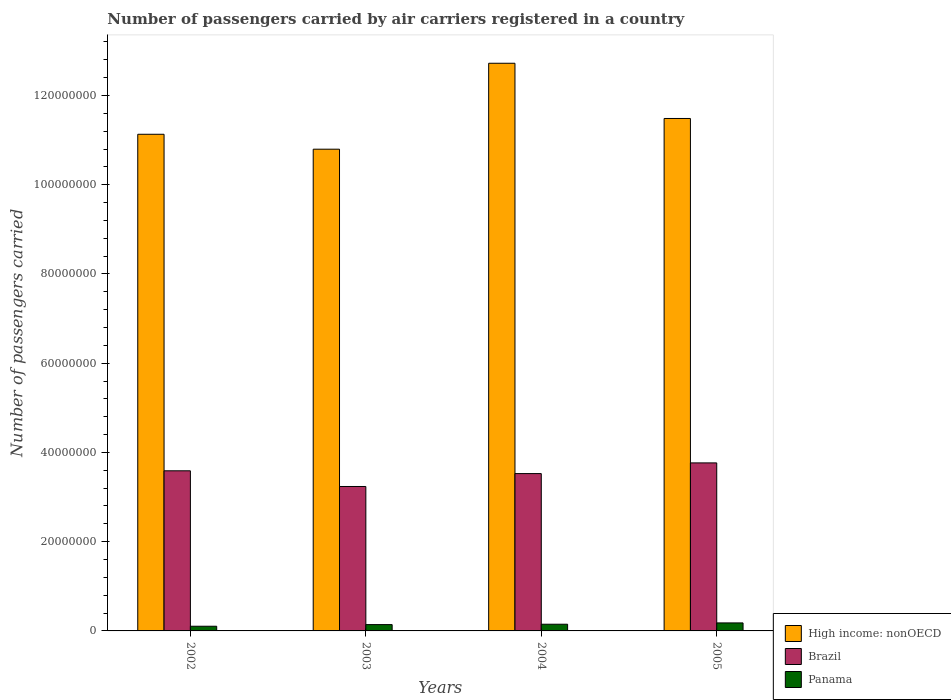How many different coloured bars are there?
Keep it short and to the point. 3. Are the number of bars per tick equal to the number of legend labels?
Your answer should be very brief. Yes. Are the number of bars on each tick of the X-axis equal?
Provide a short and direct response. Yes. In how many cases, is the number of bars for a given year not equal to the number of legend labels?
Make the answer very short. 0. What is the number of passengers carried by air carriers in Panama in 2005?
Your response must be concise. 1.80e+06. Across all years, what is the maximum number of passengers carried by air carriers in Brazil?
Your answer should be very brief. 3.77e+07. Across all years, what is the minimum number of passengers carried by air carriers in Brazil?
Provide a short and direct response. 3.24e+07. In which year was the number of passengers carried by air carriers in Panama maximum?
Your answer should be compact. 2005. In which year was the number of passengers carried by air carriers in High income: nonOECD minimum?
Your answer should be very brief. 2003. What is the total number of passengers carried by air carriers in High income: nonOECD in the graph?
Ensure brevity in your answer.  4.61e+08. What is the difference between the number of passengers carried by air carriers in Brazil in 2002 and that in 2004?
Give a very brief answer. 6.26e+05. What is the difference between the number of passengers carried by air carriers in Brazil in 2002 and the number of passengers carried by air carriers in Panama in 2004?
Provide a succinct answer. 3.44e+07. What is the average number of passengers carried by air carriers in Panama per year?
Provide a short and direct response. 1.44e+06. In the year 2003, what is the difference between the number of passengers carried by air carriers in High income: nonOECD and number of passengers carried by air carriers in Panama?
Keep it short and to the point. 1.07e+08. What is the ratio of the number of passengers carried by air carriers in High income: nonOECD in 2003 to that in 2005?
Offer a terse response. 0.94. Is the number of passengers carried by air carriers in Brazil in 2002 less than that in 2003?
Offer a terse response. No. Is the difference between the number of passengers carried by air carriers in High income: nonOECD in 2002 and 2005 greater than the difference between the number of passengers carried by air carriers in Panama in 2002 and 2005?
Give a very brief answer. No. What is the difference between the highest and the second highest number of passengers carried by air carriers in Brazil?
Offer a terse response. 1.77e+06. What is the difference between the highest and the lowest number of passengers carried by air carriers in Brazil?
Your response must be concise. 5.29e+06. In how many years, is the number of passengers carried by air carriers in High income: nonOECD greater than the average number of passengers carried by air carriers in High income: nonOECD taken over all years?
Offer a very short reply. 1. Is the sum of the number of passengers carried by air carriers in High income: nonOECD in 2004 and 2005 greater than the maximum number of passengers carried by air carriers in Panama across all years?
Your answer should be very brief. Yes. What does the 3rd bar from the left in 2002 represents?
Your response must be concise. Panama. What does the 2nd bar from the right in 2002 represents?
Keep it short and to the point. Brazil. Are all the bars in the graph horizontal?
Offer a very short reply. No. Does the graph contain grids?
Provide a short and direct response. No. How many legend labels are there?
Provide a succinct answer. 3. How are the legend labels stacked?
Offer a very short reply. Vertical. What is the title of the graph?
Offer a terse response. Number of passengers carried by air carriers registered in a country. Does "Europe(all income levels)" appear as one of the legend labels in the graph?
Give a very brief answer. No. What is the label or title of the X-axis?
Give a very brief answer. Years. What is the label or title of the Y-axis?
Give a very brief answer. Number of passengers carried. What is the Number of passengers carried of High income: nonOECD in 2002?
Give a very brief answer. 1.11e+08. What is the Number of passengers carried in Brazil in 2002?
Provide a short and direct response. 3.59e+07. What is the Number of passengers carried in Panama in 2002?
Give a very brief answer. 1.05e+06. What is the Number of passengers carried of High income: nonOECD in 2003?
Offer a terse response. 1.08e+08. What is the Number of passengers carried in Brazil in 2003?
Provide a short and direct response. 3.24e+07. What is the Number of passengers carried in Panama in 2003?
Your answer should be compact. 1.42e+06. What is the Number of passengers carried of High income: nonOECD in 2004?
Give a very brief answer. 1.27e+08. What is the Number of passengers carried of Brazil in 2004?
Provide a succinct answer. 3.53e+07. What is the Number of passengers carried of Panama in 2004?
Your answer should be compact. 1.50e+06. What is the Number of passengers carried in High income: nonOECD in 2005?
Keep it short and to the point. 1.15e+08. What is the Number of passengers carried of Brazil in 2005?
Offer a very short reply. 3.77e+07. What is the Number of passengers carried in Panama in 2005?
Your answer should be very brief. 1.80e+06. Across all years, what is the maximum Number of passengers carried of High income: nonOECD?
Give a very brief answer. 1.27e+08. Across all years, what is the maximum Number of passengers carried of Brazil?
Keep it short and to the point. 3.77e+07. Across all years, what is the maximum Number of passengers carried in Panama?
Offer a very short reply. 1.80e+06. Across all years, what is the minimum Number of passengers carried in High income: nonOECD?
Ensure brevity in your answer.  1.08e+08. Across all years, what is the minimum Number of passengers carried in Brazil?
Your answer should be very brief. 3.24e+07. Across all years, what is the minimum Number of passengers carried in Panama?
Your answer should be compact. 1.05e+06. What is the total Number of passengers carried of High income: nonOECD in the graph?
Ensure brevity in your answer.  4.61e+08. What is the total Number of passengers carried of Brazil in the graph?
Offer a very short reply. 1.41e+08. What is the total Number of passengers carried of Panama in the graph?
Provide a succinct answer. 5.76e+06. What is the difference between the Number of passengers carried in High income: nonOECD in 2002 and that in 2003?
Give a very brief answer. 3.34e+06. What is the difference between the Number of passengers carried in Brazil in 2002 and that in 2003?
Provide a succinct answer. 3.52e+06. What is the difference between the Number of passengers carried of Panama in 2002 and that in 2003?
Ensure brevity in your answer.  -3.68e+05. What is the difference between the Number of passengers carried in High income: nonOECD in 2002 and that in 2004?
Your answer should be compact. -1.59e+07. What is the difference between the Number of passengers carried in Brazil in 2002 and that in 2004?
Offer a very short reply. 6.26e+05. What is the difference between the Number of passengers carried of Panama in 2002 and that in 2004?
Provide a succinct answer. -4.53e+05. What is the difference between the Number of passengers carried of High income: nonOECD in 2002 and that in 2005?
Give a very brief answer. -3.54e+06. What is the difference between the Number of passengers carried in Brazil in 2002 and that in 2005?
Provide a short and direct response. -1.77e+06. What is the difference between the Number of passengers carried of Panama in 2002 and that in 2005?
Offer a very short reply. -7.48e+05. What is the difference between the Number of passengers carried of High income: nonOECD in 2003 and that in 2004?
Give a very brief answer. -1.93e+07. What is the difference between the Number of passengers carried in Brazil in 2003 and that in 2004?
Your response must be concise. -2.89e+06. What is the difference between the Number of passengers carried of Panama in 2003 and that in 2004?
Give a very brief answer. -8.46e+04. What is the difference between the Number of passengers carried of High income: nonOECD in 2003 and that in 2005?
Your answer should be compact. -6.89e+06. What is the difference between the Number of passengers carried of Brazil in 2003 and that in 2005?
Your answer should be compact. -5.29e+06. What is the difference between the Number of passengers carried in Panama in 2003 and that in 2005?
Keep it short and to the point. -3.80e+05. What is the difference between the Number of passengers carried of High income: nonOECD in 2004 and that in 2005?
Provide a short and direct response. 1.24e+07. What is the difference between the Number of passengers carried in Brazil in 2004 and that in 2005?
Ensure brevity in your answer.  -2.40e+06. What is the difference between the Number of passengers carried of Panama in 2004 and that in 2005?
Provide a short and direct response. -2.95e+05. What is the difference between the Number of passengers carried in High income: nonOECD in 2002 and the Number of passengers carried in Brazil in 2003?
Offer a very short reply. 7.89e+07. What is the difference between the Number of passengers carried of High income: nonOECD in 2002 and the Number of passengers carried of Panama in 2003?
Make the answer very short. 1.10e+08. What is the difference between the Number of passengers carried of Brazil in 2002 and the Number of passengers carried of Panama in 2003?
Your response must be concise. 3.45e+07. What is the difference between the Number of passengers carried of High income: nonOECD in 2002 and the Number of passengers carried of Brazil in 2004?
Offer a very short reply. 7.61e+07. What is the difference between the Number of passengers carried of High income: nonOECD in 2002 and the Number of passengers carried of Panama in 2004?
Your answer should be very brief. 1.10e+08. What is the difference between the Number of passengers carried in Brazil in 2002 and the Number of passengers carried in Panama in 2004?
Ensure brevity in your answer.  3.44e+07. What is the difference between the Number of passengers carried of High income: nonOECD in 2002 and the Number of passengers carried of Brazil in 2005?
Make the answer very short. 7.37e+07. What is the difference between the Number of passengers carried in High income: nonOECD in 2002 and the Number of passengers carried in Panama in 2005?
Provide a succinct answer. 1.10e+08. What is the difference between the Number of passengers carried of Brazil in 2002 and the Number of passengers carried of Panama in 2005?
Make the answer very short. 3.41e+07. What is the difference between the Number of passengers carried in High income: nonOECD in 2003 and the Number of passengers carried in Brazil in 2004?
Your answer should be compact. 7.27e+07. What is the difference between the Number of passengers carried of High income: nonOECD in 2003 and the Number of passengers carried of Panama in 2004?
Your answer should be very brief. 1.06e+08. What is the difference between the Number of passengers carried of Brazil in 2003 and the Number of passengers carried of Panama in 2004?
Offer a terse response. 3.09e+07. What is the difference between the Number of passengers carried of High income: nonOECD in 2003 and the Number of passengers carried of Brazil in 2005?
Offer a terse response. 7.03e+07. What is the difference between the Number of passengers carried in High income: nonOECD in 2003 and the Number of passengers carried in Panama in 2005?
Offer a terse response. 1.06e+08. What is the difference between the Number of passengers carried in Brazil in 2003 and the Number of passengers carried in Panama in 2005?
Keep it short and to the point. 3.06e+07. What is the difference between the Number of passengers carried of High income: nonOECD in 2004 and the Number of passengers carried of Brazil in 2005?
Your answer should be very brief. 8.96e+07. What is the difference between the Number of passengers carried in High income: nonOECD in 2004 and the Number of passengers carried in Panama in 2005?
Your response must be concise. 1.25e+08. What is the difference between the Number of passengers carried of Brazil in 2004 and the Number of passengers carried of Panama in 2005?
Your response must be concise. 3.35e+07. What is the average Number of passengers carried in High income: nonOECD per year?
Ensure brevity in your answer.  1.15e+08. What is the average Number of passengers carried in Brazil per year?
Your answer should be very brief. 3.53e+07. What is the average Number of passengers carried in Panama per year?
Your response must be concise. 1.44e+06. In the year 2002, what is the difference between the Number of passengers carried in High income: nonOECD and Number of passengers carried in Brazil?
Your response must be concise. 7.54e+07. In the year 2002, what is the difference between the Number of passengers carried in High income: nonOECD and Number of passengers carried in Panama?
Ensure brevity in your answer.  1.10e+08. In the year 2002, what is the difference between the Number of passengers carried in Brazil and Number of passengers carried in Panama?
Your response must be concise. 3.48e+07. In the year 2003, what is the difference between the Number of passengers carried of High income: nonOECD and Number of passengers carried of Brazil?
Offer a terse response. 7.56e+07. In the year 2003, what is the difference between the Number of passengers carried of High income: nonOECD and Number of passengers carried of Panama?
Provide a short and direct response. 1.07e+08. In the year 2003, what is the difference between the Number of passengers carried in Brazil and Number of passengers carried in Panama?
Give a very brief answer. 3.10e+07. In the year 2004, what is the difference between the Number of passengers carried of High income: nonOECD and Number of passengers carried of Brazil?
Your response must be concise. 9.20e+07. In the year 2004, what is the difference between the Number of passengers carried in High income: nonOECD and Number of passengers carried in Panama?
Make the answer very short. 1.26e+08. In the year 2004, what is the difference between the Number of passengers carried in Brazil and Number of passengers carried in Panama?
Your answer should be very brief. 3.38e+07. In the year 2005, what is the difference between the Number of passengers carried of High income: nonOECD and Number of passengers carried of Brazil?
Ensure brevity in your answer.  7.72e+07. In the year 2005, what is the difference between the Number of passengers carried of High income: nonOECD and Number of passengers carried of Panama?
Offer a very short reply. 1.13e+08. In the year 2005, what is the difference between the Number of passengers carried in Brazil and Number of passengers carried in Panama?
Offer a terse response. 3.59e+07. What is the ratio of the Number of passengers carried in High income: nonOECD in 2002 to that in 2003?
Ensure brevity in your answer.  1.03. What is the ratio of the Number of passengers carried of Brazil in 2002 to that in 2003?
Make the answer very short. 1.11. What is the ratio of the Number of passengers carried in Panama in 2002 to that in 2003?
Provide a short and direct response. 0.74. What is the ratio of the Number of passengers carried in High income: nonOECD in 2002 to that in 2004?
Offer a terse response. 0.87. What is the ratio of the Number of passengers carried of Brazil in 2002 to that in 2004?
Your answer should be very brief. 1.02. What is the ratio of the Number of passengers carried in Panama in 2002 to that in 2004?
Give a very brief answer. 0.7. What is the ratio of the Number of passengers carried in High income: nonOECD in 2002 to that in 2005?
Provide a succinct answer. 0.97. What is the ratio of the Number of passengers carried in Brazil in 2002 to that in 2005?
Provide a succinct answer. 0.95. What is the ratio of the Number of passengers carried of Panama in 2002 to that in 2005?
Provide a short and direct response. 0.58. What is the ratio of the Number of passengers carried in High income: nonOECD in 2003 to that in 2004?
Give a very brief answer. 0.85. What is the ratio of the Number of passengers carried in Brazil in 2003 to that in 2004?
Keep it short and to the point. 0.92. What is the ratio of the Number of passengers carried in Panama in 2003 to that in 2004?
Your answer should be compact. 0.94. What is the ratio of the Number of passengers carried of High income: nonOECD in 2003 to that in 2005?
Provide a succinct answer. 0.94. What is the ratio of the Number of passengers carried of Brazil in 2003 to that in 2005?
Make the answer very short. 0.86. What is the ratio of the Number of passengers carried of Panama in 2003 to that in 2005?
Offer a very short reply. 0.79. What is the ratio of the Number of passengers carried in High income: nonOECD in 2004 to that in 2005?
Provide a short and direct response. 1.11. What is the ratio of the Number of passengers carried of Brazil in 2004 to that in 2005?
Your answer should be compact. 0.94. What is the ratio of the Number of passengers carried of Panama in 2004 to that in 2005?
Make the answer very short. 0.84. What is the difference between the highest and the second highest Number of passengers carried in High income: nonOECD?
Your response must be concise. 1.24e+07. What is the difference between the highest and the second highest Number of passengers carried of Brazil?
Give a very brief answer. 1.77e+06. What is the difference between the highest and the second highest Number of passengers carried in Panama?
Your answer should be very brief. 2.95e+05. What is the difference between the highest and the lowest Number of passengers carried in High income: nonOECD?
Provide a short and direct response. 1.93e+07. What is the difference between the highest and the lowest Number of passengers carried in Brazil?
Ensure brevity in your answer.  5.29e+06. What is the difference between the highest and the lowest Number of passengers carried in Panama?
Give a very brief answer. 7.48e+05. 